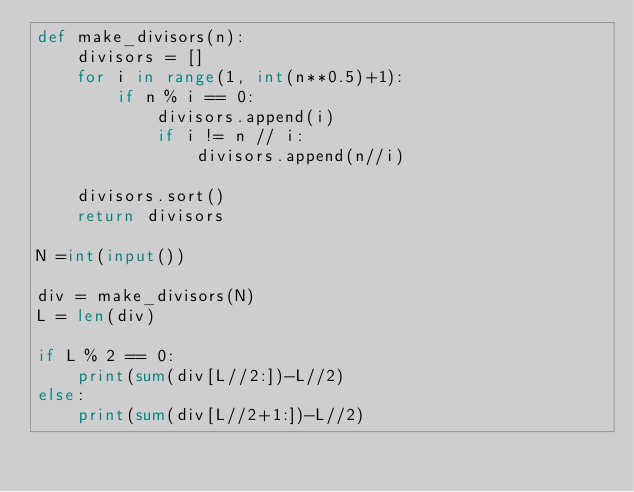Convert code to text. <code><loc_0><loc_0><loc_500><loc_500><_Python_>def make_divisors(n):
    divisors = []
    for i in range(1, int(n**0.5)+1):
        if n % i == 0:
            divisors.append(i)
            if i != n // i:
                divisors.append(n//i)

    divisors.sort()
    return divisors

N =int(input())

div = make_divisors(N)
L = len(div)

if L % 2 == 0:
    print(sum(div[L//2:])-L//2)
else:
    print(sum(div[L//2+1:])-L//2)
</code> 